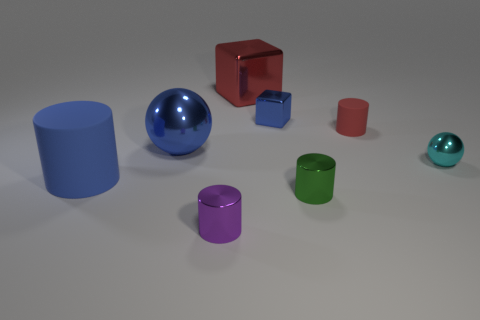Are there any other small things that have the same shape as the blue rubber object?
Your answer should be compact. Yes. What shape is the blue object that is the same size as the green metallic thing?
Provide a succinct answer. Cube. Do the tiny matte thing and the big metallic object that is behind the blue block have the same color?
Provide a short and direct response. Yes. What number of purple objects are in front of the small cylinder that is in front of the green metallic thing?
Give a very brief answer. 0. There is a cylinder that is to the left of the large red shiny block and behind the purple object; what size is it?
Give a very brief answer. Large. Is there a green object that has the same size as the purple thing?
Provide a succinct answer. Yes. Is the number of large spheres that are to the right of the tiny blue block greater than the number of small green metal cylinders right of the cyan metallic sphere?
Keep it short and to the point. No. Is the material of the small red cylinder the same as the blue object in front of the tiny cyan metallic ball?
Offer a terse response. Yes. There is a cylinder on the left side of the large blue object that is behind the blue rubber cylinder; how many tiny blue things are in front of it?
Your answer should be very brief. 0. There is a small purple thing; does it have the same shape as the object behind the blue shiny block?
Provide a short and direct response. No. 